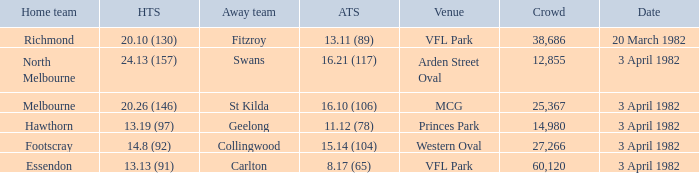Which home team played the away team of collingwood? Footscray. 